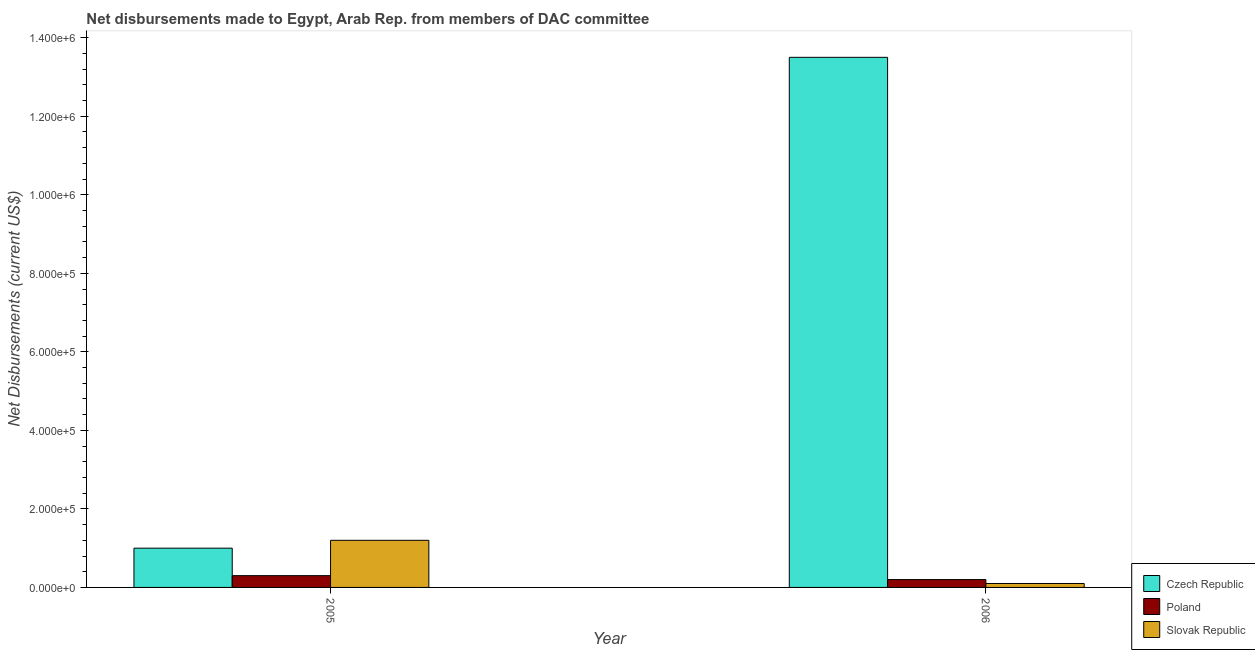How many different coloured bars are there?
Ensure brevity in your answer.  3. How many bars are there on the 1st tick from the left?
Your response must be concise. 3. How many bars are there on the 2nd tick from the right?
Your answer should be very brief. 3. In how many cases, is the number of bars for a given year not equal to the number of legend labels?
Keep it short and to the point. 0. What is the net disbursements made by poland in 2005?
Ensure brevity in your answer.  3.00e+04. Across all years, what is the maximum net disbursements made by czech republic?
Keep it short and to the point. 1.35e+06. Across all years, what is the minimum net disbursements made by poland?
Your response must be concise. 2.00e+04. In which year was the net disbursements made by poland minimum?
Your response must be concise. 2006. What is the total net disbursements made by czech republic in the graph?
Provide a short and direct response. 1.45e+06. What is the difference between the net disbursements made by poland in 2005 and that in 2006?
Ensure brevity in your answer.  10000. What is the difference between the net disbursements made by slovak republic in 2006 and the net disbursements made by czech republic in 2005?
Provide a succinct answer. -1.10e+05. What is the average net disbursements made by czech republic per year?
Provide a short and direct response. 7.25e+05. In the year 2006, what is the difference between the net disbursements made by czech republic and net disbursements made by poland?
Provide a succinct answer. 0. In how many years, is the net disbursements made by poland greater than 200000 US$?
Ensure brevity in your answer.  0. Is the net disbursements made by czech republic in 2005 less than that in 2006?
Your response must be concise. Yes. What does the 3rd bar from the right in 2006 represents?
Provide a succinct answer. Czech Republic. How many bars are there?
Keep it short and to the point. 6. Are all the bars in the graph horizontal?
Ensure brevity in your answer.  No. How many years are there in the graph?
Provide a short and direct response. 2. Are the values on the major ticks of Y-axis written in scientific E-notation?
Offer a very short reply. Yes. Does the graph contain grids?
Offer a terse response. No. How many legend labels are there?
Your answer should be compact. 3. How are the legend labels stacked?
Give a very brief answer. Vertical. What is the title of the graph?
Make the answer very short. Net disbursements made to Egypt, Arab Rep. from members of DAC committee. Does "Other sectors" appear as one of the legend labels in the graph?
Provide a succinct answer. No. What is the label or title of the X-axis?
Offer a very short reply. Year. What is the label or title of the Y-axis?
Provide a succinct answer. Net Disbursements (current US$). What is the Net Disbursements (current US$) in Czech Republic in 2005?
Offer a very short reply. 1.00e+05. What is the Net Disbursements (current US$) of Czech Republic in 2006?
Ensure brevity in your answer.  1.35e+06. What is the Net Disbursements (current US$) in Poland in 2006?
Provide a succinct answer. 2.00e+04. Across all years, what is the maximum Net Disbursements (current US$) in Czech Republic?
Provide a short and direct response. 1.35e+06. Across all years, what is the maximum Net Disbursements (current US$) in Poland?
Provide a succinct answer. 3.00e+04. Across all years, what is the minimum Net Disbursements (current US$) in Poland?
Ensure brevity in your answer.  2.00e+04. Across all years, what is the minimum Net Disbursements (current US$) in Slovak Republic?
Your answer should be very brief. 10000. What is the total Net Disbursements (current US$) in Czech Republic in the graph?
Your answer should be compact. 1.45e+06. What is the difference between the Net Disbursements (current US$) of Czech Republic in 2005 and that in 2006?
Your response must be concise. -1.25e+06. What is the difference between the Net Disbursements (current US$) in Czech Republic in 2005 and the Net Disbursements (current US$) in Slovak Republic in 2006?
Offer a very short reply. 9.00e+04. What is the difference between the Net Disbursements (current US$) in Poland in 2005 and the Net Disbursements (current US$) in Slovak Republic in 2006?
Ensure brevity in your answer.  2.00e+04. What is the average Net Disbursements (current US$) in Czech Republic per year?
Your answer should be very brief. 7.25e+05. What is the average Net Disbursements (current US$) of Poland per year?
Provide a short and direct response. 2.50e+04. What is the average Net Disbursements (current US$) in Slovak Republic per year?
Give a very brief answer. 6.50e+04. In the year 2005, what is the difference between the Net Disbursements (current US$) in Czech Republic and Net Disbursements (current US$) in Slovak Republic?
Your answer should be compact. -2.00e+04. In the year 2006, what is the difference between the Net Disbursements (current US$) in Czech Republic and Net Disbursements (current US$) in Poland?
Provide a short and direct response. 1.33e+06. In the year 2006, what is the difference between the Net Disbursements (current US$) in Czech Republic and Net Disbursements (current US$) in Slovak Republic?
Offer a very short reply. 1.34e+06. In the year 2006, what is the difference between the Net Disbursements (current US$) of Poland and Net Disbursements (current US$) of Slovak Republic?
Your answer should be compact. 10000. What is the ratio of the Net Disbursements (current US$) of Czech Republic in 2005 to that in 2006?
Provide a short and direct response. 0.07. What is the ratio of the Net Disbursements (current US$) of Poland in 2005 to that in 2006?
Ensure brevity in your answer.  1.5. What is the difference between the highest and the second highest Net Disbursements (current US$) in Czech Republic?
Your response must be concise. 1.25e+06. What is the difference between the highest and the second highest Net Disbursements (current US$) in Slovak Republic?
Make the answer very short. 1.10e+05. What is the difference between the highest and the lowest Net Disbursements (current US$) in Czech Republic?
Ensure brevity in your answer.  1.25e+06. What is the difference between the highest and the lowest Net Disbursements (current US$) of Poland?
Your answer should be very brief. 10000. What is the difference between the highest and the lowest Net Disbursements (current US$) in Slovak Republic?
Your answer should be very brief. 1.10e+05. 